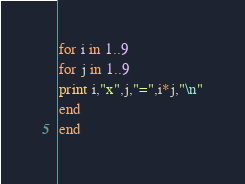Convert code to text. <code><loc_0><loc_0><loc_500><loc_500><_Ruby_>for i in 1..9
for j in 1..9
print i,"x",j,"=",i*j,"\n"
end
end</code> 